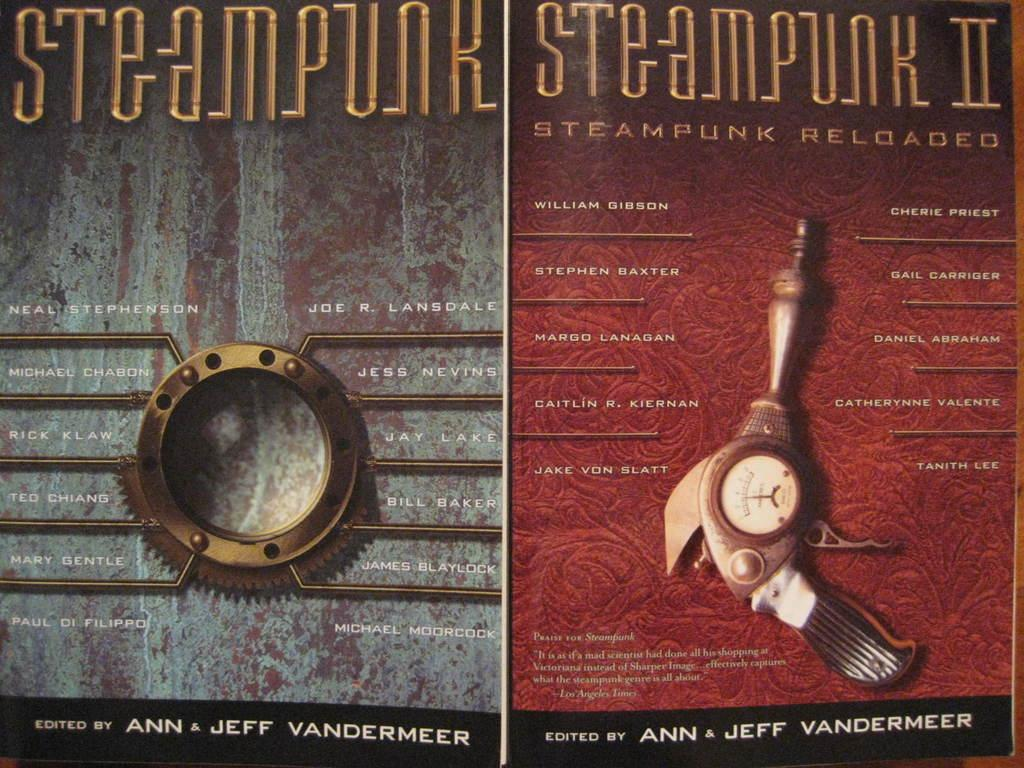Provide a one-sentence caption for the provided image. A poster promoting Steampunk and Steampunk 2 both edited by Ann & Jeff Vandermeer. 